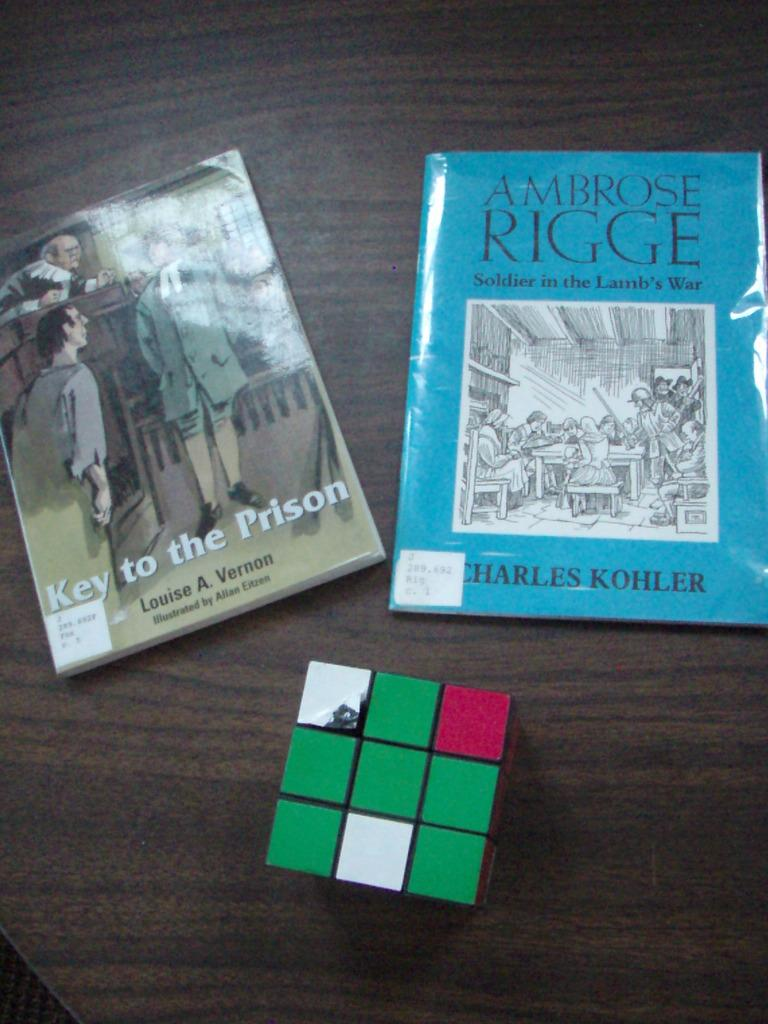Provide a one-sentence caption for the provided image. A copy of Key to the Prison sits on a table near another book and a Rubik's cube. 